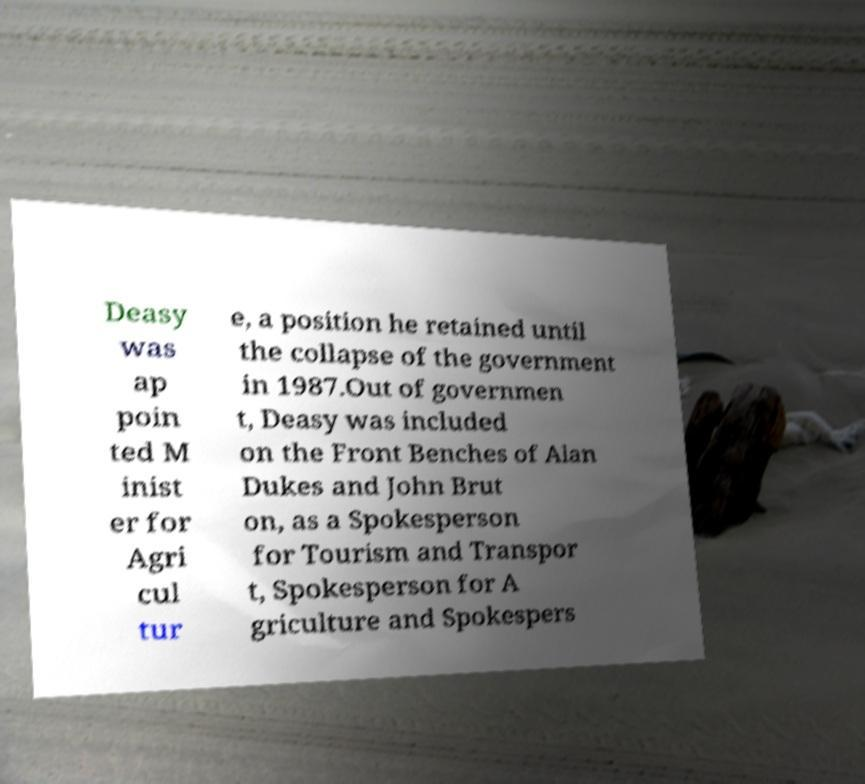I need the written content from this picture converted into text. Can you do that? Deasy was ap poin ted M inist er for Agri cul tur e, a position he retained until the collapse of the government in 1987.Out of governmen t, Deasy was included on the Front Benches of Alan Dukes and John Brut on, as a Spokesperson for Tourism and Transpor t, Spokesperson for A griculture and Spokespers 